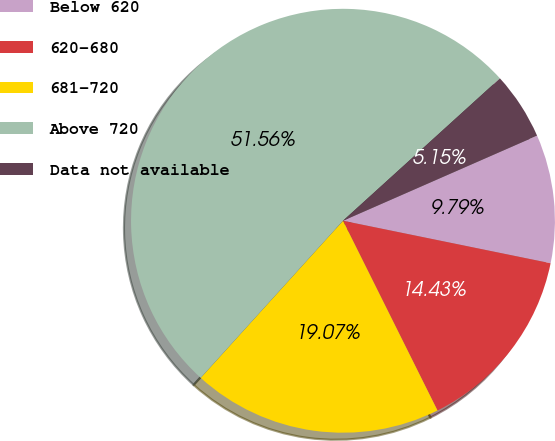Convert chart. <chart><loc_0><loc_0><loc_500><loc_500><pie_chart><fcel>Below 620<fcel>620-680<fcel>681-720<fcel>Above 720<fcel>Data not available<nl><fcel>9.79%<fcel>14.43%<fcel>19.07%<fcel>51.56%<fcel>5.15%<nl></chart> 